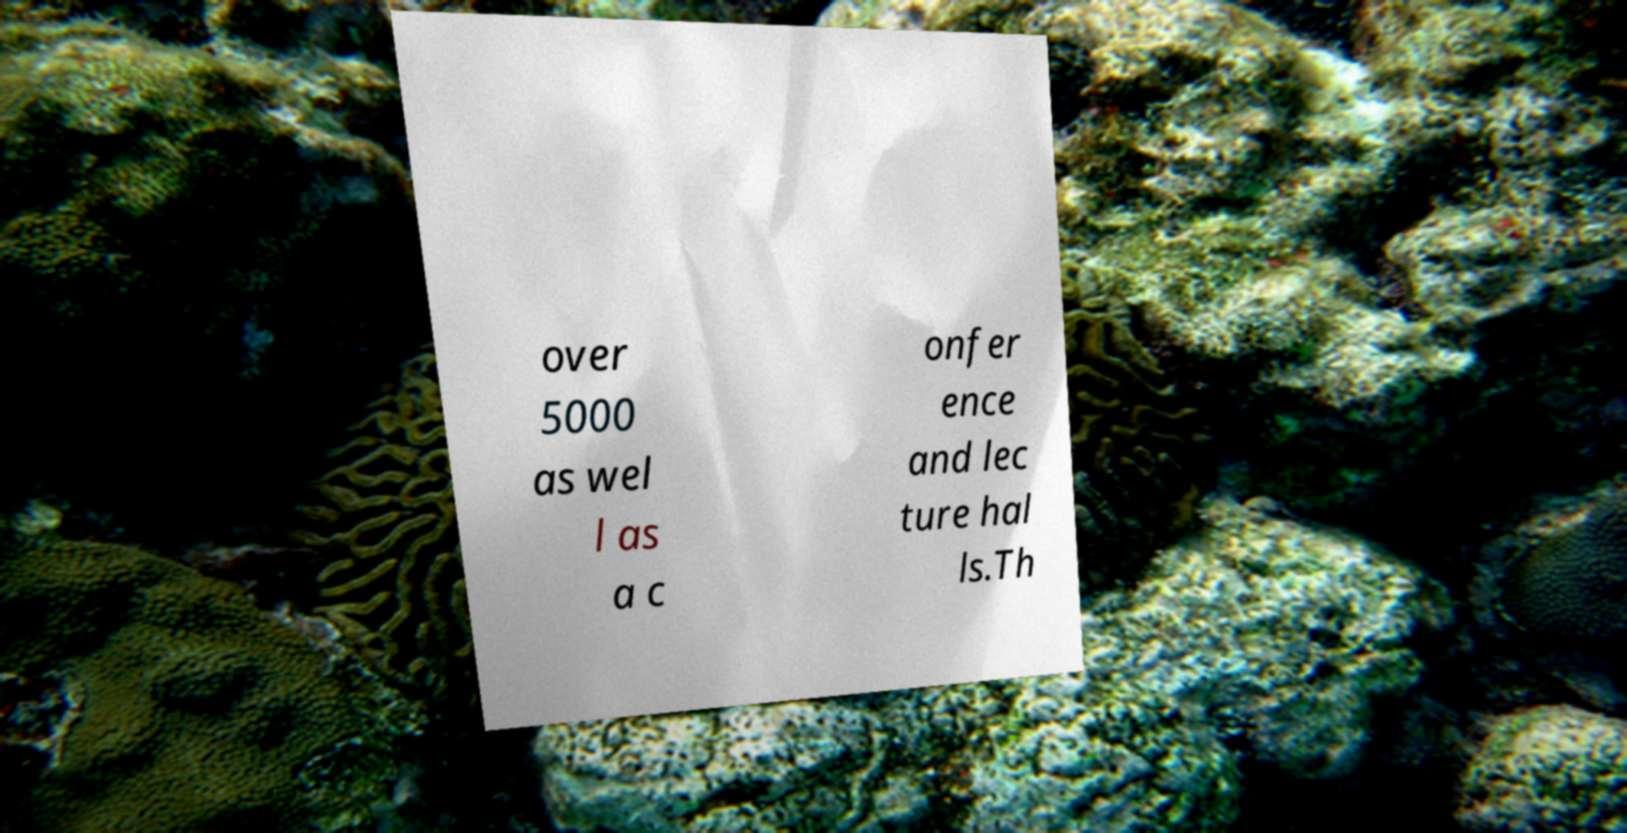Please read and relay the text visible in this image. What does it say? over 5000 as wel l as a c onfer ence and lec ture hal ls.Th 